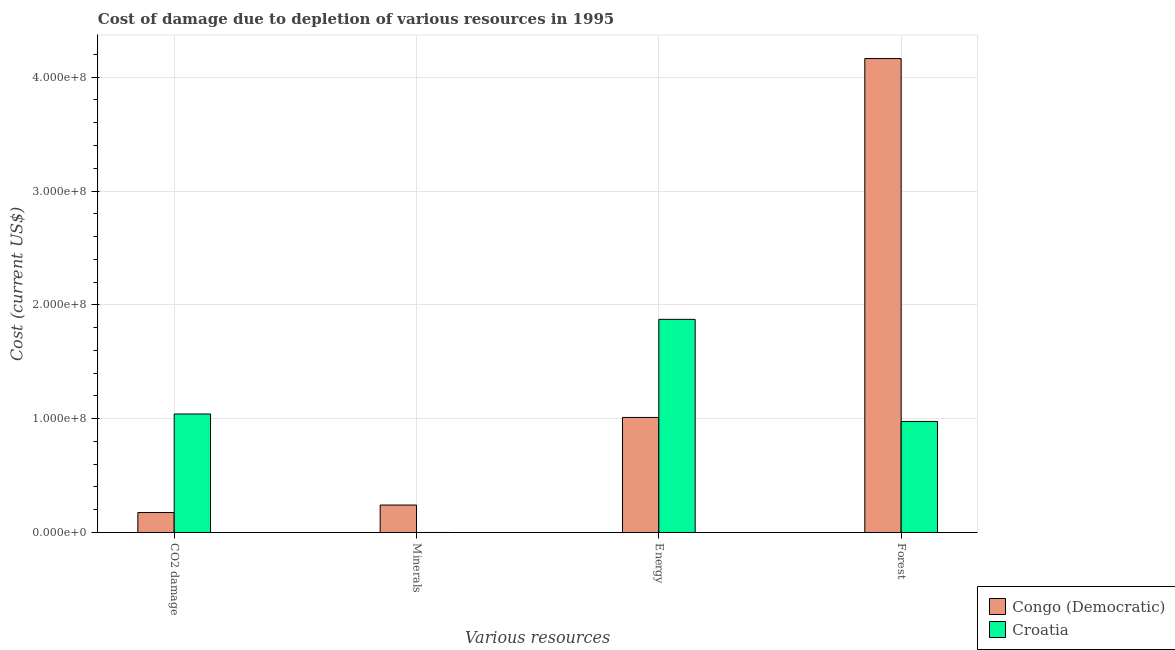Are the number of bars per tick equal to the number of legend labels?
Keep it short and to the point. Yes. How many bars are there on the 2nd tick from the right?
Your answer should be compact. 2. What is the label of the 2nd group of bars from the left?
Provide a succinct answer. Minerals. What is the cost of damage due to depletion of minerals in Croatia?
Provide a short and direct response. 3807.4. Across all countries, what is the maximum cost of damage due to depletion of minerals?
Offer a terse response. 2.41e+07. Across all countries, what is the minimum cost of damage due to depletion of energy?
Your response must be concise. 1.01e+08. In which country was the cost of damage due to depletion of energy maximum?
Ensure brevity in your answer.  Croatia. In which country was the cost of damage due to depletion of energy minimum?
Offer a terse response. Congo (Democratic). What is the total cost of damage due to depletion of forests in the graph?
Provide a succinct answer. 5.14e+08. What is the difference between the cost of damage due to depletion of energy in Congo (Democratic) and that in Croatia?
Offer a terse response. -8.62e+07. What is the difference between the cost of damage due to depletion of coal in Congo (Democratic) and the cost of damage due to depletion of minerals in Croatia?
Offer a very short reply. 1.75e+07. What is the average cost of damage due to depletion of forests per country?
Ensure brevity in your answer.  2.57e+08. What is the difference between the cost of damage due to depletion of coal and cost of damage due to depletion of minerals in Congo (Democratic)?
Provide a short and direct response. -6.58e+06. In how many countries, is the cost of damage due to depletion of coal greater than 260000000 US$?
Your response must be concise. 0. What is the ratio of the cost of damage due to depletion of energy in Congo (Democratic) to that in Croatia?
Keep it short and to the point. 0.54. Is the cost of damage due to depletion of forests in Congo (Democratic) less than that in Croatia?
Provide a short and direct response. No. Is the difference between the cost of damage due to depletion of minerals in Croatia and Congo (Democratic) greater than the difference between the cost of damage due to depletion of forests in Croatia and Congo (Democratic)?
Make the answer very short. Yes. What is the difference between the highest and the second highest cost of damage due to depletion of coal?
Keep it short and to the point. 8.65e+07. What is the difference between the highest and the lowest cost of damage due to depletion of minerals?
Keep it short and to the point. 2.41e+07. Is it the case that in every country, the sum of the cost of damage due to depletion of minerals and cost of damage due to depletion of coal is greater than the sum of cost of damage due to depletion of energy and cost of damage due to depletion of forests?
Give a very brief answer. No. What does the 1st bar from the left in Minerals represents?
Provide a short and direct response. Congo (Democratic). What does the 1st bar from the right in Forest represents?
Your answer should be compact. Croatia. How many bars are there?
Give a very brief answer. 8. Are all the bars in the graph horizontal?
Your response must be concise. No. How many countries are there in the graph?
Provide a succinct answer. 2. Does the graph contain grids?
Ensure brevity in your answer.  Yes. What is the title of the graph?
Offer a terse response. Cost of damage due to depletion of various resources in 1995 . What is the label or title of the X-axis?
Your answer should be very brief. Various resources. What is the label or title of the Y-axis?
Your answer should be compact. Cost (current US$). What is the Cost (current US$) of Congo (Democratic) in CO2 damage?
Your answer should be compact. 1.75e+07. What is the Cost (current US$) in Croatia in CO2 damage?
Make the answer very short. 1.04e+08. What is the Cost (current US$) of Congo (Democratic) in Minerals?
Keep it short and to the point. 2.41e+07. What is the Cost (current US$) of Croatia in Minerals?
Give a very brief answer. 3807.4. What is the Cost (current US$) of Congo (Democratic) in Energy?
Provide a succinct answer. 1.01e+08. What is the Cost (current US$) in Croatia in Energy?
Provide a succinct answer. 1.87e+08. What is the Cost (current US$) of Congo (Democratic) in Forest?
Your answer should be compact. 4.16e+08. What is the Cost (current US$) of Croatia in Forest?
Make the answer very short. 9.76e+07. Across all Various resources, what is the maximum Cost (current US$) in Congo (Democratic)?
Give a very brief answer. 4.16e+08. Across all Various resources, what is the maximum Cost (current US$) in Croatia?
Ensure brevity in your answer.  1.87e+08. Across all Various resources, what is the minimum Cost (current US$) of Congo (Democratic)?
Give a very brief answer. 1.75e+07. Across all Various resources, what is the minimum Cost (current US$) of Croatia?
Offer a very short reply. 3807.4. What is the total Cost (current US$) of Congo (Democratic) in the graph?
Keep it short and to the point. 5.59e+08. What is the total Cost (current US$) of Croatia in the graph?
Give a very brief answer. 3.89e+08. What is the difference between the Cost (current US$) of Congo (Democratic) in CO2 damage and that in Minerals?
Provide a succinct answer. -6.58e+06. What is the difference between the Cost (current US$) of Croatia in CO2 damage and that in Minerals?
Give a very brief answer. 1.04e+08. What is the difference between the Cost (current US$) of Congo (Democratic) in CO2 damage and that in Energy?
Ensure brevity in your answer.  -8.35e+07. What is the difference between the Cost (current US$) in Croatia in CO2 damage and that in Energy?
Your answer should be very brief. -8.32e+07. What is the difference between the Cost (current US$) in Congo (Democratic) in CO2 damage and that in Forest?
Offer a terse response. -3.99e+08. What is the difference between the Cost (current US$) of Croatia in CO2 damage and that in Forest?
Your answer should be compact. 6.52e+06. What is the difference between the Cost (current US$) of Congo (Democratic) in Minerals and that in Energy?
Keep it short and to the point. -7.70e+07. What is the difference between the Cost (current US$) of Croatia in Minerals and that in Energy?
Provide a succinct answer. -1.87e+08. What is the difference between the Cost (current US$) in Congo (Democratic) in Minerals and that in Forest?
Provide a short and direct response. -3.92e+08. What is the difference between the Cost (current US$) of Croatia in Minerals and that in Forest?
Your answer should be very brief. -9.76e+07. What is the difference between the Cost (current US$) in Congo (Democratic) in Energy and that in Forest?
Provide a short and direct response. -3.15e+08. What is the difference between the Cost (current US$) of Croatia in Energy and that in Forest?
Provide a succinct answer. 8.97e+07. What is the difference between the Cost (current US$) in Congo (Democratic) in CO2 damage and the Cost (current US$) in Croatia in Minerals?
Your response must be concise. 1.75e+07. What is the difference between the Cost (current US$) of Congo (Democratic) in CO2 damage and the Cost (current US$) of Croatia in Energy?
Ensure brevity in your answer.  -1.70e+08. What is the difference between the Cost (current US$) of Congo (Democratic) in CO2 damage and the Cost (current US$) of Croatia in Forest?
Make the answer very short. -8.00e+07. What is the difference between the Cost (current US$) in Congo (Democratic) in Minerals and the Cost (current US$) in Croatia in Energy?
Ensure brevity in your answer.  -1.63e+08. What is the difference between the Cost (current US$) of Congo (Democratic) in Minerals and the Cost (current US$) of Croatia in Forest?
Give a very brief answer. -7.35e+07. What is the difference between the Cost (current US$) in Congo (Democratic) in Energy and the Cost (current US$) in Croatia in Forest?
Offer a very short reply. 3.50e+06. What is the average Cost (current US$) of Congo (Democratic) per Various resources?
Ensure brevity in your answer.  1.40e+08. What is the average Cost (current US$) of Croatia per Various resources?
Ensure brevity in your answer.  9.72e+07. What is the difference between the Cost (current US$) of Congo (Democratic) and Cost (current US$) of Croatia in CO2 damage?
Give a very brief answer. -8.65e+07. What is the difference between the Cost (current US$) in Congo (Democratic) and Cost (current US$) in Croatia in Minerals?
Offer a terse response. 2.41e+07. What is the difference between the Cost (current US$) of Congo (Democratic) and Cost (current US$) of Croatia in Energy?
Give a very brief answer. -8.62e+07. What is the difference between the Cost (current US$) of Congo (Democratic) and Cost (current US$) of Croatia in Forest?
Offer a very short reply. 3.19e+08. What is the ratio of the Cost (current US$) of Congo (Democratic) in CO2 damage to that in Minerals?
Make the answer very short. 0.73. What is the ratio of the Cost (current US$) in Croatia in CO2 damage to that in Minerals?
Offer a very short reply. 2.73e+04. What is the ratio of the Cost (current US$) in Congo (Democratic) in CO2 damage to that in Energy?
Make the answer very short. 0.17. What is the ratio of the Cost (current US$) of Croatia in CO2 damage to that in Energy?
Your answer should be compact. 0.56. What is the ratio of the Cost (current US$) of Congo (Democratic) in CO2 damage to that in Forest?
Provide a short and direct response. 0.04. What is the ratio of the Cost (current US$) in Croatia in CO2 damage to that in Forest?
Keep it short and to the point. 1.07. What is the ratio of the Cost (current US$) of Congo (Democratic) in Minerals to that in Energy?
Provide a short and direct response. 0.24. What is the ratio of the Cost (current US$) in Croatia in Minerals to that in Energy?
Keep it short and to the point. 0. What is the ratio of the Cost (current US$) in Congo (Democratic) in Minerals to that in Forest?
Provide a short and direct response. 0.06. What is the ratio of the Cost (current US$) of Congo (Democratic) in Energy to that in Forest?
Give a very brief answer. 0.24. What is the ratio of the Cost (current US$) of Croatia in Energy to that in Forest?
Provide a succinct answer. 1.92. What is the difference between the highest and the second highest Cost (current US$) of Congo (Democratic)?
Keep it short and to the point. 3.15e+08. What is the difference between the highest and the second highest Cost (current US$) in Croatia?
Your answer should be compact. 8.32e+07. What is the difference between the highest and the lowest Cost (current US$) of Congo (Democratic)?
Keep it short and to the point. 3.99e+08. What is the difference between the highest and the lowest Cost (current US$) of Croatia?
Provide a short and direct response. 1.87e+08. 